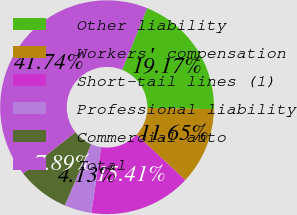Convert chart to OTSL. <chart><loc_0><loc_0><loc_500><loc_500><pie_chart><fcel>Other liability<fcel>Workers' compensation<fcel>Short-tail lines (1)<fcel>Professional liability<fcel>Commercial auto<fcel>Total<nl><fcel>19.17%<fcel>11.65%<fcel>15.41%<fcel>4.13%<fcel>7.89%<fcel>41.74%<nl></chart> 